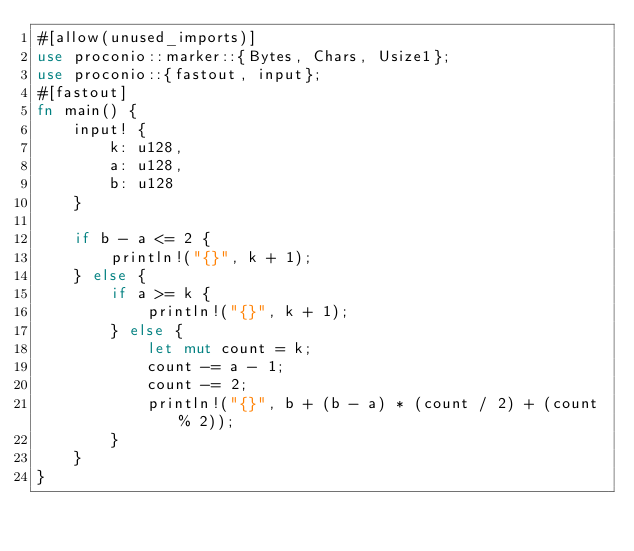Convert code to text. <code><loc_0><loc_0><loc_500><loc_500><_Rust_>#[allow(unused_imports)]
use proconio::marker::{Bytes, Chars, Usize1};
use proconio::{fastout, input};
#[fastout]
fn main() {
    input! {
        k: u128,
        a: u128,
        b: u128
    }

    if b - a <= 2 {
        println!("{}", k + 1);
    } else {
        if a >= k {
            println!("{}", k + 1);
        } else {
            let mut count = k;
            count -= a - 1;
            count -= 2;
            println!("{}", b + (b - a) * (count / 2) + (count % 2));
        }
    }
}
</code> 